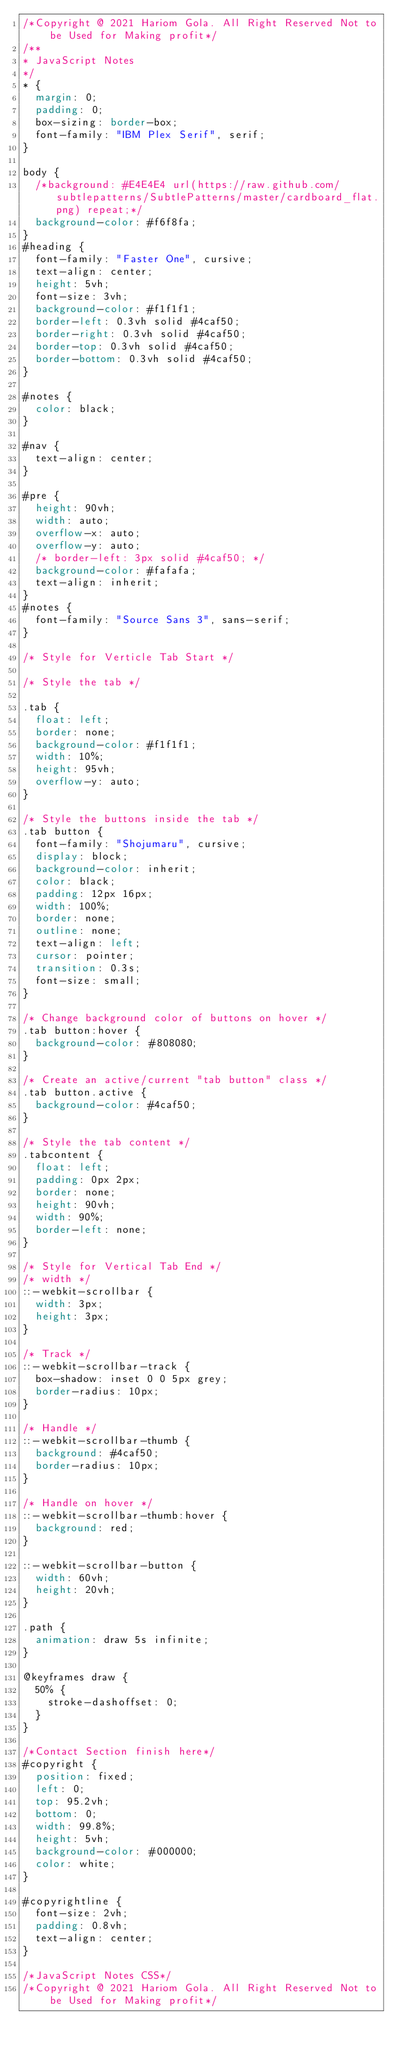Convert code to text. <code><loc_0><loc_0><loc_500><loc_500><_CSS_>/*Copyright @ 2021 Hariom Gola. All Right Reserved Not to be Used for Making profit*/
/**
* JavaScript Notes
*/
* {
  margin: 0;
  padding: 0;
  box-sizing: border-box;
  font-family: "IBM Plex Serif", serif;
}

body {
  /*background: #E4E4E4 url(https://raw.github.com/subtlepatterns/SubtlePatterns/master/cardboard_flat.png) repeat;*/
  background-color: #f6f8fa;
}
#heading {
  font-family: "Faster One", cursive;
  text-align: center;
  height: 5vh;
  font-size: 3vh;
  background-color: #f1f1f1;
  border-left: 0.3vh solid #4caf50;
  border-right: 0.3vh solid #4caf50;
  border-top: 0.3vh solid #4caf50;
  border-bottom: 0.3vh solid #4caf50;
}

#notes {
  color: black;
}

#nav {
  text-align: center;
}

#pre {
  height: 90vh;
  width: auto;
  overflow-x: auto;
  overflow-y: auto;
  /* border-left: 3px solid #4caf50; */
  background-color: #fafafa;
  text-align: inherit;
}
#notes {
  font-family: "Source Sans 3", sans-serif;
}

/* Style for Verticle Tab Start */

/* Style the tab */

.tab {
  float: left;
  border: none;
  background-color: #f1f1f1;
  width: 10%;
  height: 95vh;
  overflow-y: auto;
}

/* Style the buttons inside the tab */
.tab button {
  font-family: "Shojumaru", cursive;
  display: block;
  background-color: inherit;
  color: black;
  padding: 12px 16px;
  width: 100%;
  border: none;
  outline: none;
  text-align: left;
  cursor: pointer;
  transition: 0.3s;
  font-size: small;
}

/* Change background color of buttons on hover */
.tab button:hover {
  background-color: #808080;
}

/* Create an active/current "tab button" class */
.tab button.active {
  background-color: #4caf50;
}

/* Style the tab content */
.tabcontent {
  float: left;
  padding: 0px 2px;
  border: none;
  height: 90vh;
  width: 90%;
  border-left: none;
}

/* Style for Vertical Tab End */
/* width */
::-webkit-scrollbar {
  width: 3px;
  height: 3px;
}

/* Track */
::-webkit-scrollbar-track {
  box-shadow: inset 0 0 5px grey;
  border-radius: 10px;
}

/* Handle */
::-webkit-scrollbar-thumb {
  background: #4caf50;
  border-radius: 10px;
}

/* Handle on hover */
::-webkit-scrollbar-thumb:hover {
  background: red;
}

::-webkit-scrollbar-button {
  width: 60vh;
  height: 20vh;
}

.path {
  animation: draw 5s infinite;
}

@keyframes draw {
  50% {
    stroke-dashoffset: 0;
  }
}

/*Contact Section finish here*/
#copyright {
  position: fixed;
  left: 0;
  top: 95.2vh;
  bottom: 0;
  width: 99.8%;
  height: 5vh;
  background-color: #000000;
  color: white;
}

#copyrightline {
  font-size: 2vh;
  padding: 0.8vh;
  text-align: center;
}

/*JavaScript Notes CSS*/
/*Copyright @ 2021 Hariom Gola. All Right Reserved Not to be Used for Making profit*/
</code> 